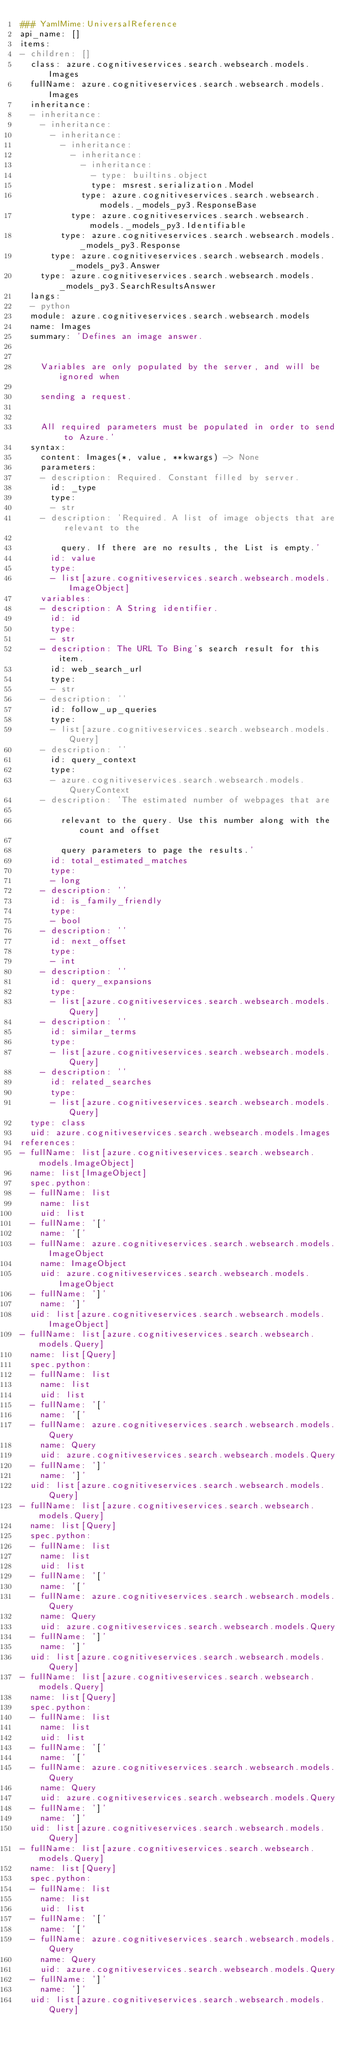Convert code to text. <code><loc_0><loc_0><loc_500><loc_500><_YAML_>### YamlMime:UniversalReference
api_name: []
items:
- children: []
  class: azure.cognitiveservices.search.websearch.models.Images
  fullName: azure.cognitiveservices.search.websearch.models.Images
  inheritance:
  - inheritance:
    - inheritance:
      - inheritance:
        - inheritance:
          - inheritance:
            - inheritance:
              - type: builtins.object
              type: msrest.serialization.Model
            type: azure.cognitiveservices.search.websearch.models._models_py3.ResponseBase
          type: azure.cognitiveservices.search.websearch.models._models_py3.Identifiable
        type: azure.cognitiveservices.search.websearch.models._models_py3.Response
      type: azure.cognitiveservices.search.websearch.models._models_py3.Answer
    type: azure.cognitiveservices.search.websearch.models._models_py3.SearchResultsAnswer
  langs:
  - python
  module: azure.cognitiveservices.search.websearch.models
  name: Images
  summary: 'Defines an image answer.


    Variables are only populated by the server, and will be ignored when

    sending a request.


    All required parameters must be populated in order to send to Azure.'
  syntax:
    content: Images(*, value, **kwargs) -> None
    parameters:
    - description: Required. Constant filled by server.
      id: _type
      type:
      - str
    - description: 'Required. A list of image objects that are relevant to the

        query. If there are no results, the List is empty.'
      id: value
      type:
      - list[azure.cognitiveservices.search.websearch.models.ImageObject]
    variables:
    - description: A String identifier.
      id: id
      type:
      - str
    - description: The URL To Bing's search result for this item.
      id: web_search_url
      type:
      - str
    - description: ''
      id: follow_up_queries
      type:
      - list[azure.cognitiveservices.search.websearch.models.Query]
    - description: ''
      id: query_context
      type:
      - azure.cognitiveservices.search.websearch.models.QueryContext
    - description: 'The estimated number of webpages that are

        relevant to the query. Use this number along with the count and offset

        query parameters to page the results.'
      id: total_estimated_matches
      type:
      - long
    - description: ''
      id: is_family_friendly
      type:
      - bool
    - description: ''
      id: next_offset
      type:
      - int
    - description: ''
      id: query_expansions
      type:
      - list[azure.cognitiveservices.search.websearch.models.Query]
    - description: ''
      id: similar_terms
      type:
      - list[azure.cognitiveservices.search.websearch.models.Query]
    - description: ''
      id: related_searches
      type:
      - list[azure.cognitiveservices.search.websearch.models.Query]
  type: class
  uid: azure.cognitiveservices.search.websearch.models.Images
references:
- fullName: list[azure.cognitiveservices.search.websearch.models.ImageObject]
  name: list[ImageObject]
  spec.python:
  - fullName: list
    name: list
    uid: list
  - fullName: '['
    name: '['
  - fullName: azure.cognitiveservices.search.websearch.models.ImageObject
    name: ImageObject
    uid: azure.cognitiveservices.search.websearch.models.ImageObject
  - fullName: ']'
    name: ']'
  uid: list[azure.cognitiveservices.search.websearch.models.ImageObject]
- fullName: list[azure.cognitiveservices.search.websearch.models.Query]
  name: list[Query]
  spec.python:
  - fullName: list
    name: list
    uid: list
  - fullName: '['
    name: '['
  - fullName: azure.cognitiveservices.search.websearch.models.Query
    name: Query
    uid: azure.cognitiveservices.search.websearch.models.Query
  - fullName: ']'
    name: ']'
  uid: list[azure.cognitiveservices.search.websearch.models.Query]
- fullName: list[azure.cognitiveservices.search.websearch.models.Query]
  name: list[Query]
  spec.python:
  - fullName: list
    name: list
    uid: list
  - fullName: '['
    name: '['
  - fullName: azure.cognitiveservices.search.websearch.models.Query
    name: Query
    uid: azure.cognitiveservices.search.websearch.models.Query
  - fullName: ']'
    name: ']'
  uid: list[azure.cognitiveservices.search.websearch.models.Query]
- fullName: list[azure.cognitiveservices.search.websearch.models.Query]
  name: list[Query]
  spec.python:
  - fullName: list
    name: list
    uid: list
  - fullName: '['
    name: '['
  - fullName: azure.cognitiveservices.search.websearch.models.Query
    name: Query
    uid: azure.cognitiveservices.search.websearch.models.Query
  - fullName: ']'
    name: ']'
  uid: list[azure.cognitiveservices.search.websearch.models.Query]
- fullName: list[azure.cognitiveservices.search.websearch.models.Query]
  name: list[Query]
  spec.python:
  - fullName: list
    name: list
    uid: list
  - fullName: '['
    name: '['
  - fullName: azure.cognitiveservices.search.websearch.models.Query
    name: Query
    uid: azure.cognitiveservices.search.websearch.models.Query
  - fullName: ']'
    name: ']'
  uid: list[azure.cognitiveservices.search.websearch.models.Query]
</code> 